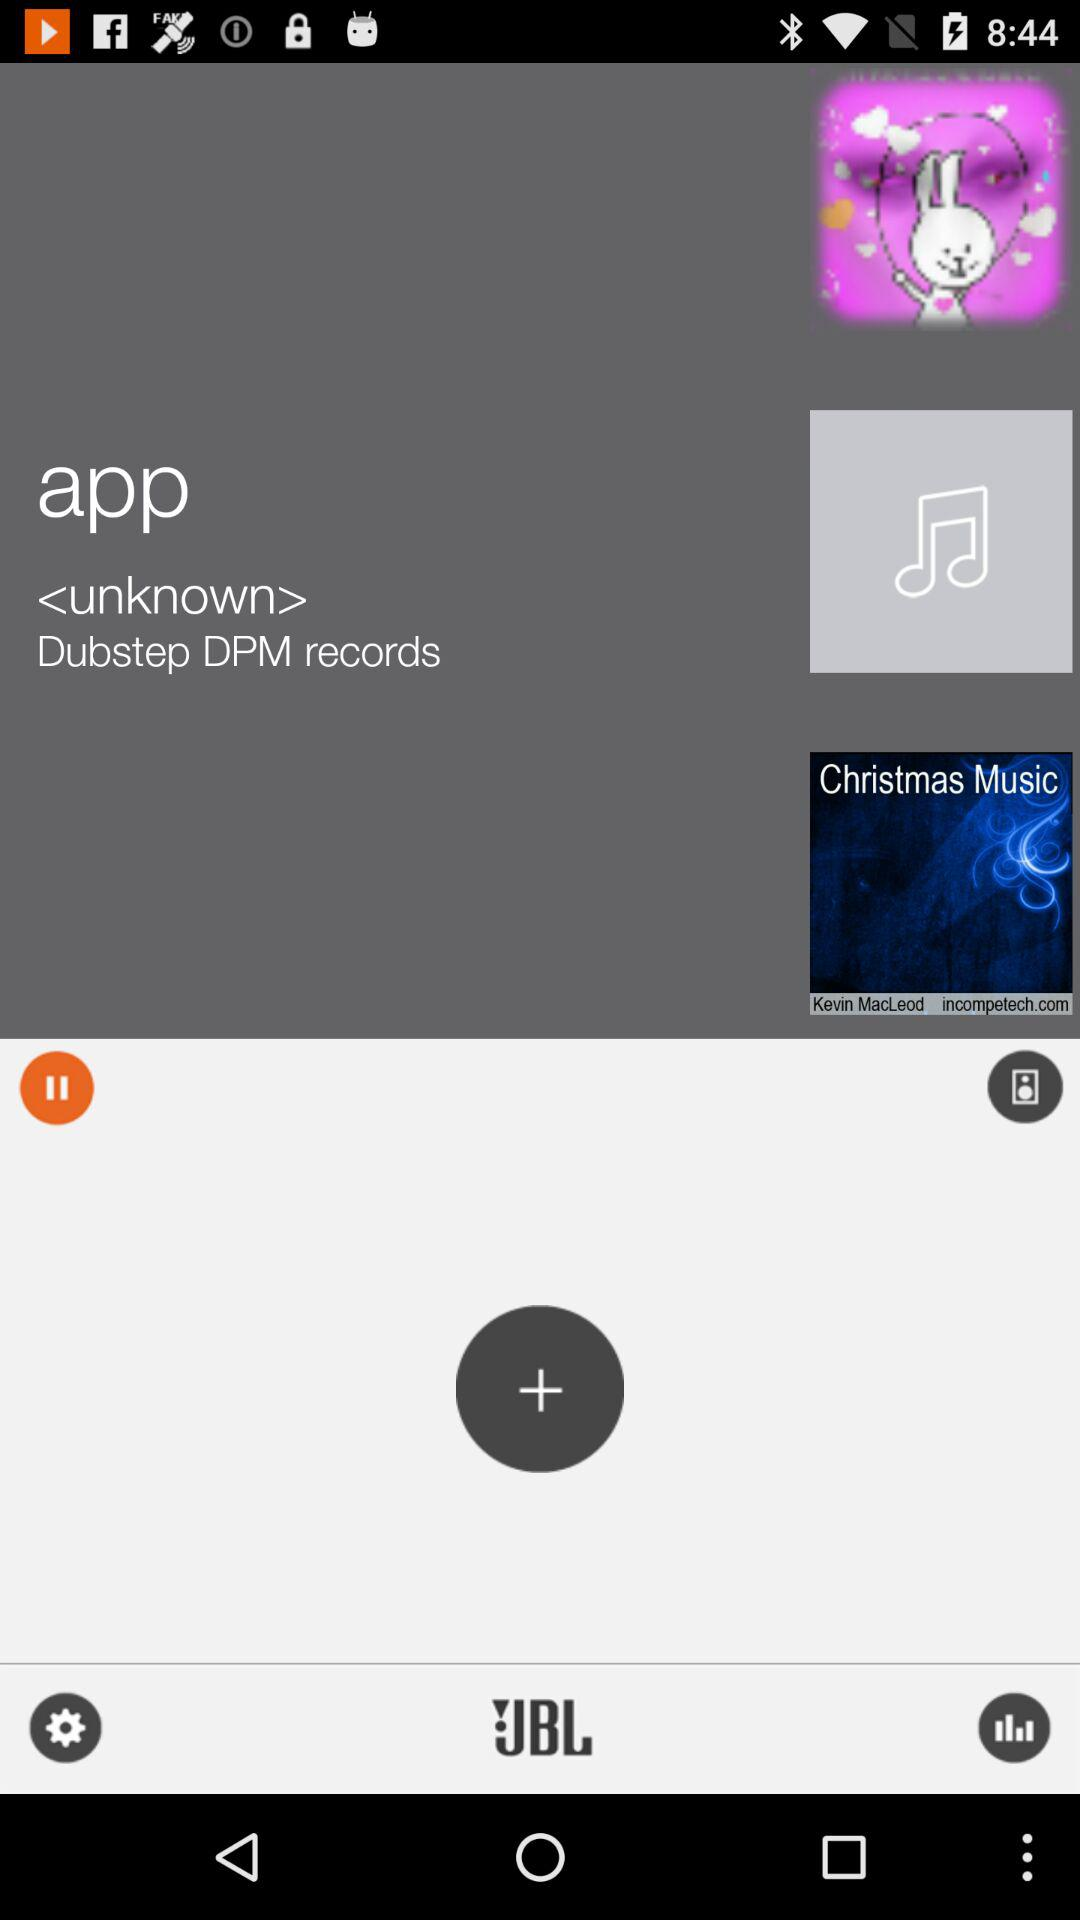What is the application name? The application name is "Dubstep DPM". 